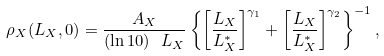<formula> <loc_0><loc_0><loc_500><loc_500>\rho _ { X } ( L _ { X } , 0 ) = \frac { A _ { X } } { ( \ln 1 0 ) \ L _ { X } } \left \{ \left [ \frac { L _ { X } } { L ^ { \ast } _ { X } } \right ] ^ { \gamma _ { 1 } } + \left [ \frac { L _ { X } } { L ^ { \ast } _ { X } } \right ] ^ { \gamma _ { 2 } } \right \} ^ { - 1 } ,</formula> 